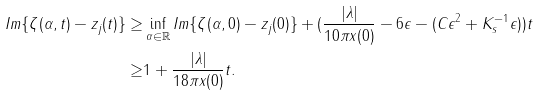<formula> <loc_0><loc_0><loc_500><loc_500>I m \{ \zeta ( \alpha , t ) - z _ { j } ( t ) \} \geq & \inf _ { \alpha \in \mathbb { R } } I m \{ \zeta ( \alpha , 0 ) - z _ { j } ( 0 ) \} + ( \frac { | \lambda | } { 1 0 \pi x ( 0 ) } - 6 \epsilon - ( C \epsilon ^ { 2 } + K _ { s } ^ { - 1 } \epsilon ) ) t \\ \geq & 1 + \frac { | \lambda | } { 1 8 \pi x ( 0 ) } t .</formula> 